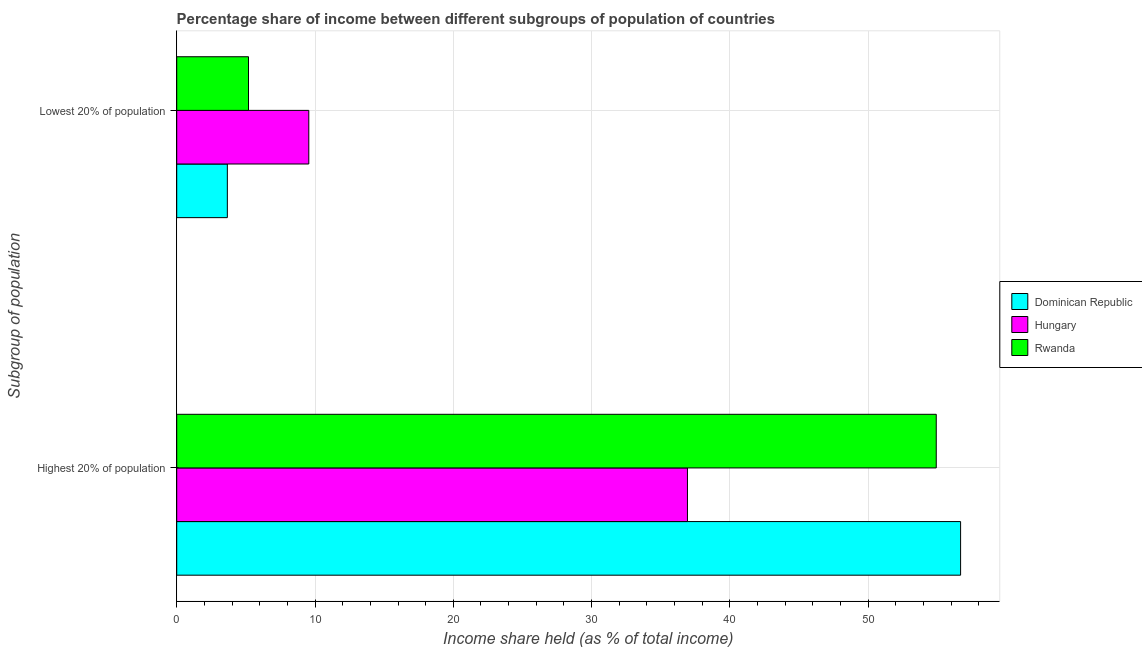How many different coloured bars are there?
Keep it short and to the point. 3. How many bars are there on the 1st tick from the top?
Your response must be concise. 3. How many bars are there on the 2nd tick from the bottom?
Provide a short and direct response. 3. What is the label of the 1st group of bars from the top?
Keep it short and to the point. Lowest 20% of population. What is the income share held by highest 20% of the population in Dominican Republic?
Provide a succinct answer. 56.68. Across all countries, what is the maximum income share held by lowest 20% of the population?
Your response must be concise. 9.55. Across all countries, what is the minimum income share held by highest 20% of the population?
Give a very brief answer. 36.93. In which country was the income share held by highest 20% of the population maximum?
Make the answer very short. Dominican Republic. In which country was the income share held by highest 20% of the population minimum?
Keep it short and to the point. Hungary. What is the total income share held by lowest 20% of the population in the graph?
Your answer should be compact. 18.4. What is the difference between the income share held by highest 20% of the population in Dominican Republic and that in Hungary?
Provide a succinct answer. 19.75. What is the difference between the income share held by highest 20% of the population in Dominican Republic and the income share held by lowest 20% of the population in Hungary?
Provide a succinct answer. 47.13. What is the average income share held by lowest 20% of the population per country?
Give a very brief answer. 6.13. What is the difference between the income share held by lowest 20% of the population and income share held by highest 20% of the population in Dominican Republic?
Offer a very short reply. -53.02. In how many countries, is the income share held by highest 20% of the population greater than 30 %?
Provide a succinct answer. 3. What is the ratio of the income share held by highest 20% of the population in Rwanda to that in Hungary?
Your response must be concise. 1.49. In how many countries, is the income share held by highest 20% of the population greater than the average income share held by highest 20% of the population taken over all countries?
Keep it short and to the point. 2. What does the 3rd bar from the top in Highest 20% of population represents?
Keep it short and to the point. Dominican Republic. What does the 3rd bar from the bottom in Lowest 20% of population represents?
Ensure brevity in your answer.  Rwanda. How many bars are there?
Provide a short and direct response. 6. Does the graph contain any zero values?
Make the answer very short. No. Does the graph contain grids?
Your answer should be compact. Yes. How many legend labels are there?
Offer a terse response. 3. What is the title of the graph?
Give a very brief answer. Percentage share of income between different subgroups of population of countries. What is the label or title of the X-axis?
Your answer should be compact. Income share held (as % of total income). What is the label or title of the Y-axis?
Your answer should be very brief. Subgroup of population. What is the Income share held (as % of total income) in Dominican Republic in Highest 20% of population?
Ensure brevity in your answer.  56.68. What is the Income share held (as % of total income) in Hungary in Highest 20% of population?
Keep it short and to the point. 36.93. What is the Income share held (as % of total income) of Rwanda in Highest 20% of population?
Your answer should be compact. 54.92. What is the Income share held (as % of total income) in Dominican Republic in Lowest 20% of population?
Offer a very short reply. 3.66. What is the Income share held (as % of total income) in Hungary in Lowest 20% of population?
Offer a very short reply. 9.55. What is the Income share held (as % of total income) in Rwanda in Lowest 20% of population?
Offer a very short reply. 5.19. Across all Subgroup of population, what is the maximum Income share held (as % of total income) in Dominican Republic?
Make the answer very short. 56.68. Across all Subgroup of population, what is the maximum Income share held (as % of total income) in Hungary?
Make the answer very short. 36.93. Across all Subgroup of population, what is the maximum Income share held (as % of total income) in Rwanda?
Offer a very short reply. 54.92. Across all Subgroup of population, what is the minimum Income share held (as % of total income) in Dominican Republic?
Offer a very short reply. 3.66. Across all Subgroup of population, what is the minimum Income share held (as % of total income) in Hungary?
Ensure brevity in your answer.  9.55. Across all Subgroup of population, what is the minimum Income share held (as % of total income) in Rwanda?
Your answer should be compact. 5.19. What is the total Income share held (as % of total income) in Dominican Republic in the graph?
Offer a terse response. 60.34. What is the total Income share held (as % of total income) of Hungary in the graph?
Your response must be concise. 46.48. What is the total Income share held (as % of total income) in Rwanda in the graph?
Provide a short and direct response. 60.11. What is the difference between the Income share held (as % of total income) in Dominican Republic in Highest 20% of population and that in Lowest 20% of population?
Offer a terse response. 53.02. What is the difference between the Income share held (as % of total income) in Hungary in Highest 20% of population and that in Lowest 20% of population?
Make the answer very short. 27.38. What is the difference between the Income share held (as % of total income) in Rwanda in Highest 20% of population and that in Lowest 20% of population?
Your answer should be very brief. 49.73. What is the difference between the Income share held (as % of total income) in Dominican Republic in Highest 20% of population and the Income share held (as % of total income) in Hungary in Lowest 20% of population?
Offer a terse response. 47.13. What is the difference between the Income share held (as % of total income) in Dominican Republic in Highest 20% of population and the Income share held (as % of total income) in Rwanda in Lowest 20% of population?
Provide a short and direct response. 51.49. What is the difference between the Income share held (as % of total income) of Hungary in Highest 20% of population and the Income share held (as % of total income) of Rwanda in Lowest 20% of population?
Provide a succinct answer. 31.74. What is the average Income share held (as % of total income) in Dominican Republic per Subgroup of population?
Offer a terse response. 30.17. What is the average Income share held (as % of total income) of Hungary per Subgroup of population?
Keep it short and to the point. 23.24. What is the average Income share held (as % of total income) of Rwanda per Subgroup of population?
Make the answer very short. 30.05. What is the difference between the Income share held (as % of total income) in Dominican Republic and Income share held (as % of total income) in Hungary in Highest 20% of population?
Keep it short and to the point. 19.75. What is the difference between the Income share held (as % of total income) in Dominican Republic and Income share held (as % of total income) in Rwanda in Highest 20% of population?
Provide a succinct answer. 1.76. What is the difference between the Income share held (as % of total income) in Hungary and Income share held (as % of total income) in Rwanda in Highest 20% of population?
Provide a short and direct response. -17.99. What is the difference between the Income share held (as % of total income) of Dominican Republic and Income share held (as % of total income) of Hungary in Lowest 20% of population?
Make the answer very short. -5.89. What is the difference between the Income share held (as % of total income) of Dominican Republic and Income share held (as % of total income) of Rwanda in Lowest 20% of population?
Provide a succinct answer. -1.53. What is the difference between the Income share held (as % of total income) of Hungary and Income share held (as % of total income) of Rwanda in Lowest 20% of population?
Offer a terse response. 4.36. What is the ratio of the Income share held (as % of total income) of Dominican Republic in Highest 20% of population to that in Lowest 20% of population?
Offer a terse response. 15.49. What is the ratio of the Income share held (as % of total income) of Hungary in Highest 20% of population to that in Lowest 20% of population?
Provide a short and direct response. 3.87. What is the ratio of the Income share held (as % of total income) in Rwanda in Highest 20% of population to that in Lowest 20% of population?
Your answer should be compact. 10.58. What is the difference between the highest and the second highest Income share held (as % of total income) of Dominican Republic?
Ensure brevity in your answer.  53.02. What is the difference between the highest and the second highest Income share held (as % of total income) of Hungary?
Provide a succinct answer. 27.38. What is the difference between the highest and the second highest Income share held (as % of total income) of Rwanda?
Give a very brief answer. 49.73. What is the difference between the highest and the lowest Income share held (as % of total income) of Dominican Republic?
Your response must be concise. 53.02. What is the difference between the highest and the lowest Income share held (as % of total income) in Hungary?
Offer a terse response. 27.38. What is the difference between the highest and the lowest Income share held (as % of total income) in Rwanda?
Provide a short and direct response. 49.73. 